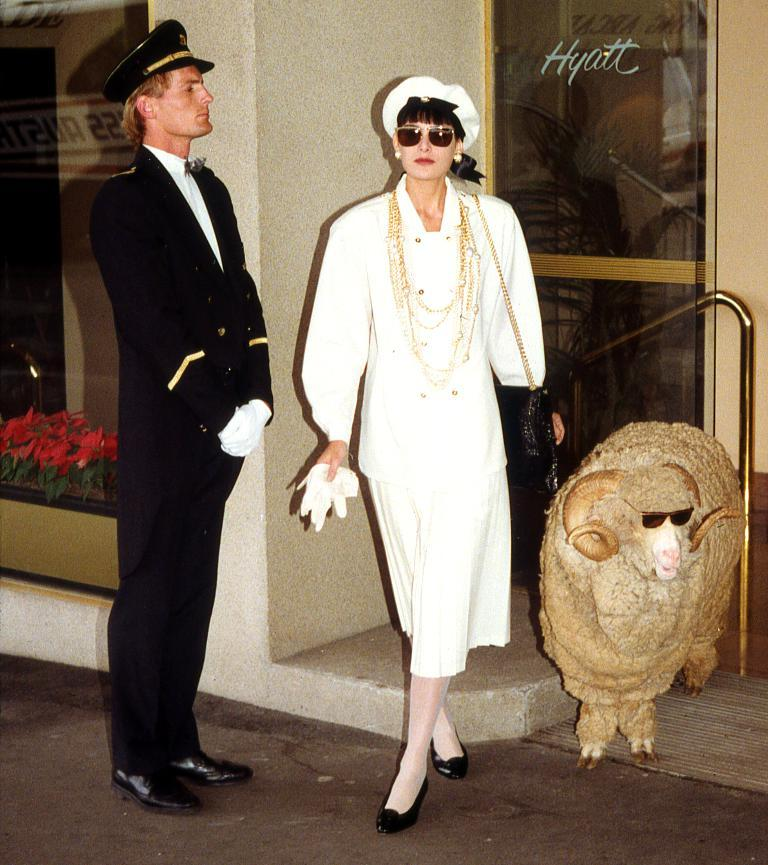How many people are in the image? There is a man and a woman in the image. What other living creature is present in the image? There is a sheep in the image. Where are the man, woman, and sheep located in the image? They are standing near a wall. What is beside the wall in the image? There is a glass door beside the wall. What type of prose is being recited by the sheep in the image? There is no indication in the image that the sheep is reciting any prose, as sheep do not have the ability to speak or recite literature. 